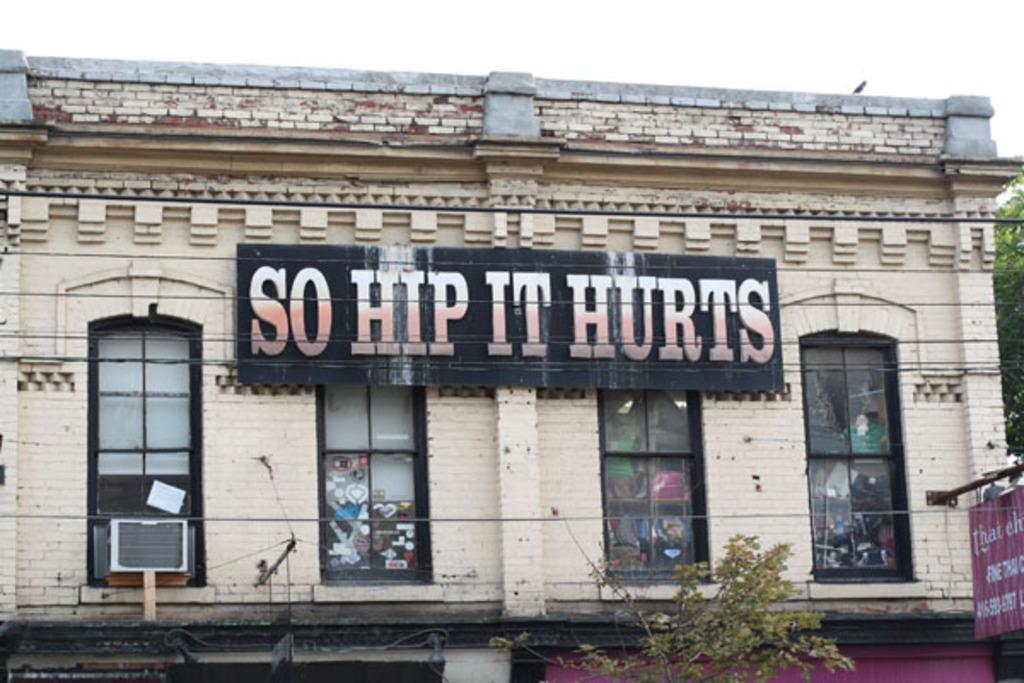Could you give a brief overview of what you see in this image? In this image there is a building with the four windows. There is a hoarding to the wall. At the bottom there is a plant. At the top there is sky. 